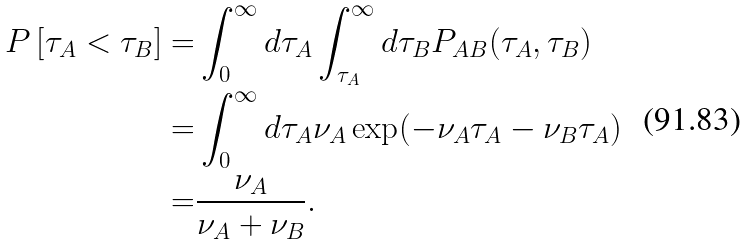<formula> <loc_0><loc_0><loc_500><loc_500>P \left [ \tau _ { A } < \tau _ { B } \right ] = & \int _ { 0 } ^ { \infty } d \tau _ { A } \int _ { \tau _ { A } } ^ { \infty } d \tau _ { B } P _ { A B } ( \tau _ { A } , \tau _ { B } ) \\ = & \int _ { 0 } ^ { \infty } d \tau _ { A } \nu _ { A } \exp ( - \nu _ { A } \tau _ { A } - \nu _ { B } \tau _ { A } ) \\ = & \frac { \nu _ { A } } { \nu _ { A } + \nu _ { B } } .</formula> 